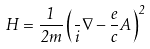Convert formula to latex. <formula><loc_0><loc_0><loc_500><loc_500>H = \frac { 1 } { 2 m } \left ( \frac { } { i } \nabla - \frac { e } { c } { A } \right ) ^ { 2 }</formula> 